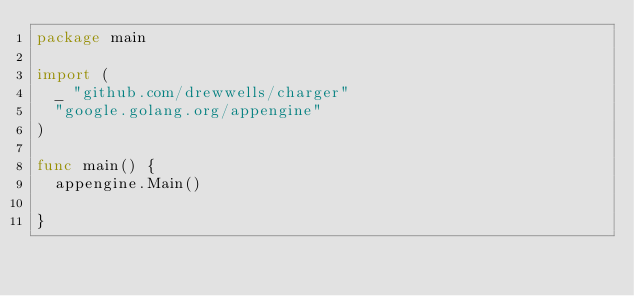Convert code to text. <code><loc_0><loc_0><loc_500><loc_500><_Go_>package main

import (
	_ "github.com/drewwells/charger"
	"google.golang.org/appengine"
)

func main() {
	appengine.Main()

}
</code> 